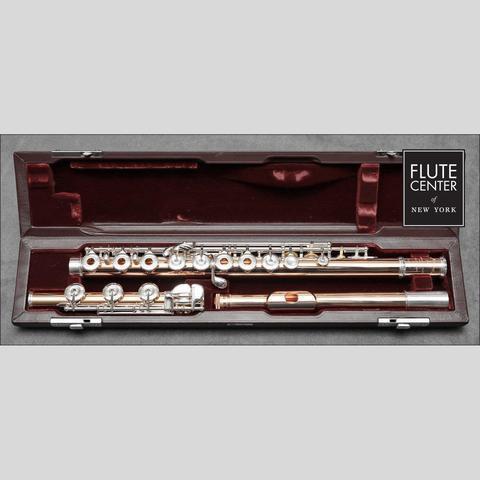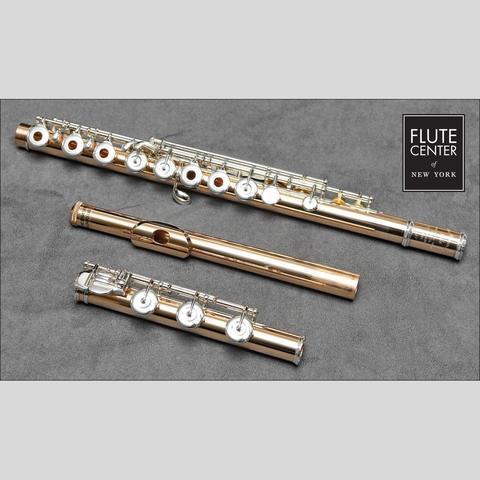The first image is the image on the left, the second image is the image on the right. Analyze the images presented: Is the assertion "One image shows a shiny pale gold flute in parts inside an open case." valid? Answer yes or no. Yes. The first image is the image on the left, the second image is the image on the right. Considering the images on both sides, is "All the flutes are assembled." valid? Answer yes or no. No. 